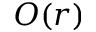Convert formula to latex. <formula><loc_0><loc_0><loc_500><loc_500>O ( r )</formula> 